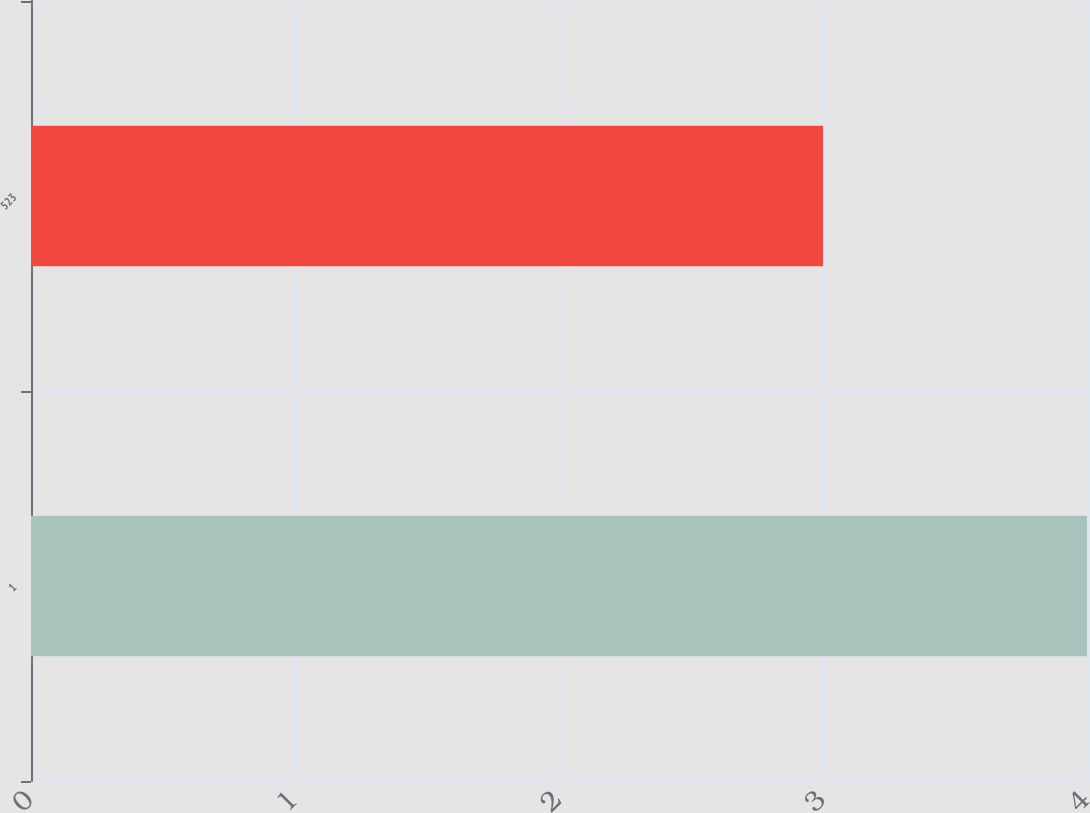Convert chart to OTSL. <chart><loc_0><loc_0><loc_500><loc_500><bar_chart><fcel>1<fcel>523<nl><fcel>4<fcel>3<nl></chart> 